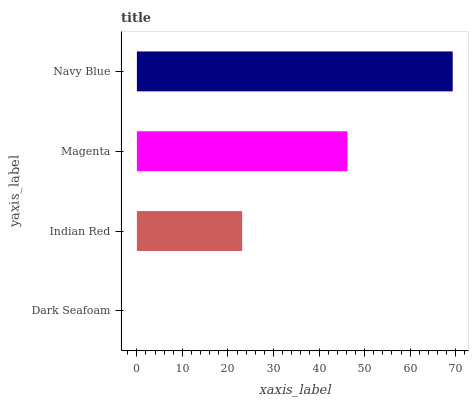Is Dark Seafoam the minimum?
Answer yes or no. Yes. Is Navy Blue the maximum?
Answer yes or no. Yes. Is Indian Red the minimum?
Answer yes or no. No. Is Indian Red the maximum?
Answer yes or no. No. Is Indian Red greater than Dark Seafoam?
Answer yes or no. Yes. Is Dark Seafoam less than Indian Red?
Answer yes or no. Yes. Is Dark Seafoam greater than Indian Red?
Answer yes or no. No. Is Indian Red less than Dark Seafoam?
Answer yes or no. No. Is Magenta the high median?
Answer yes or no. Yes. Is Indian Red the low median?
Answer yes or no. Yes. Is Indian Red the high median?
Answer yes or no. No. Is Magenta the low median?
Answer yes or no. No. 